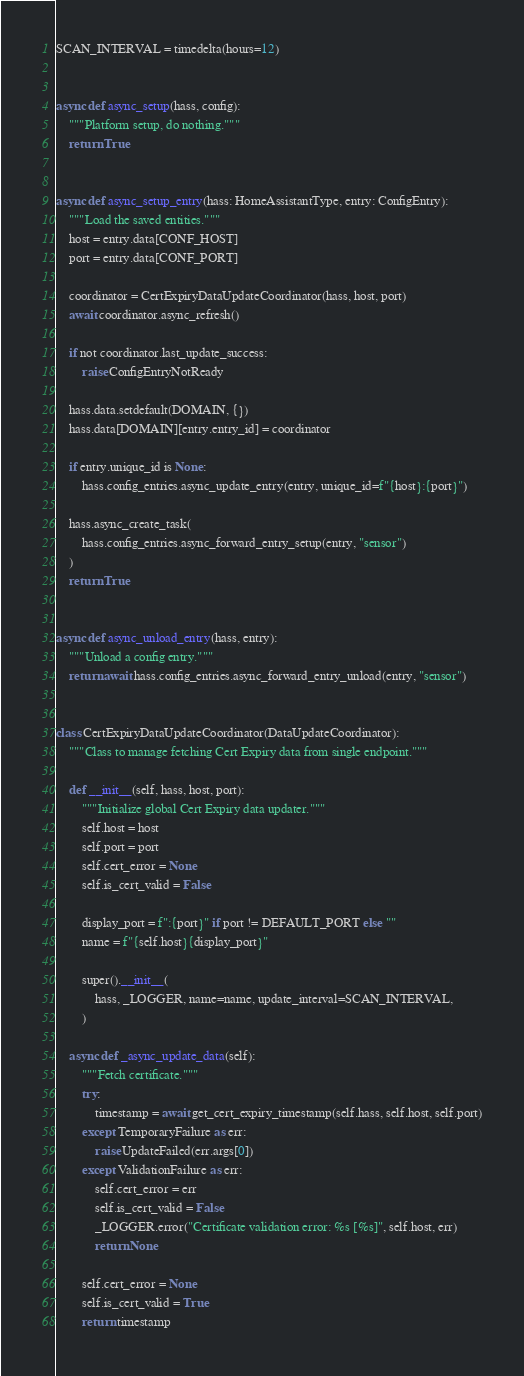<code> <loc_0><loc_0><loc_500><loc_500><_Python_>
SCAN_INTERVAL = timedelta(hours=12)


async def async_setup(hass, config):
    """Platform setup, do nothing."""
    return True


async def async_setup_entry(hass: HomeAssistantType, entry: ConfigEntry):
    """Load the saved entities."""
    host = entry.data[CONF_HOST]
    port = entry.data[CONF_PORT]

    coordinator = CertExpiryDataUpdateCoordinator(hass, host, port)
    await coordinator.async_refresh()

    if not coordinator.last_update_success:
        raise ConfigEntryNotReady

    hass.data.setdefault(DOMAIN, {})
    hass.data[DOMAIN][entry.entry_id] = coordinator

    if entry.unique_id is None:
        hass.config_entries.async_update_entry(entry, unique_id=f"{host}:{port}")

    hass.async_create_task(
        hass.config_entries.async_forward_entry_setup(entry, "sensor")
    )
    return True


async def async_unload_entry(hass, entry):
    """Unload a config entry."""
    return await hass.config_entries.async_forward_entry_unload(entry, "sensor")


class CertExpiryDataUpdateCoordinator(DataUpdateCoordinator):
    """Class to manage fetching Cert Expiry data from single endpoint."""

    def __init__(self, hass, host, port):
        """Initialize global Cert Expiry data updater."""
        self.host = host
        self.port = port
        self.cert_error = None
        self.is_cert_valid = False

        display_port = f":{port}" if port != DEFAULT_PORT else ""
        name = f"{self.host}{display_port}"

        super().__init__(
            hass, _LOGGER, name=name, update_interval=SCAN_INTERVAL,
        )

    async def _async_update_data(self):
        """Fetch certificate."""
        try:
            timestamp = await get_cert_expiry_timestamp(self.hass, self.host, self.port)
        except TemporaryFailure as err:
            raise UpdateFailed(err.args[0])
        except ValidationFailure as err:
            self.cert_error = err
            self.is_cert_valid = False
            _LOGGER.error("Certificate validation error: %s [%s]", self.host, err)
            return None

        self.cert_error = None
        self.is_cert_valid = True
        return timestamp
</code> 